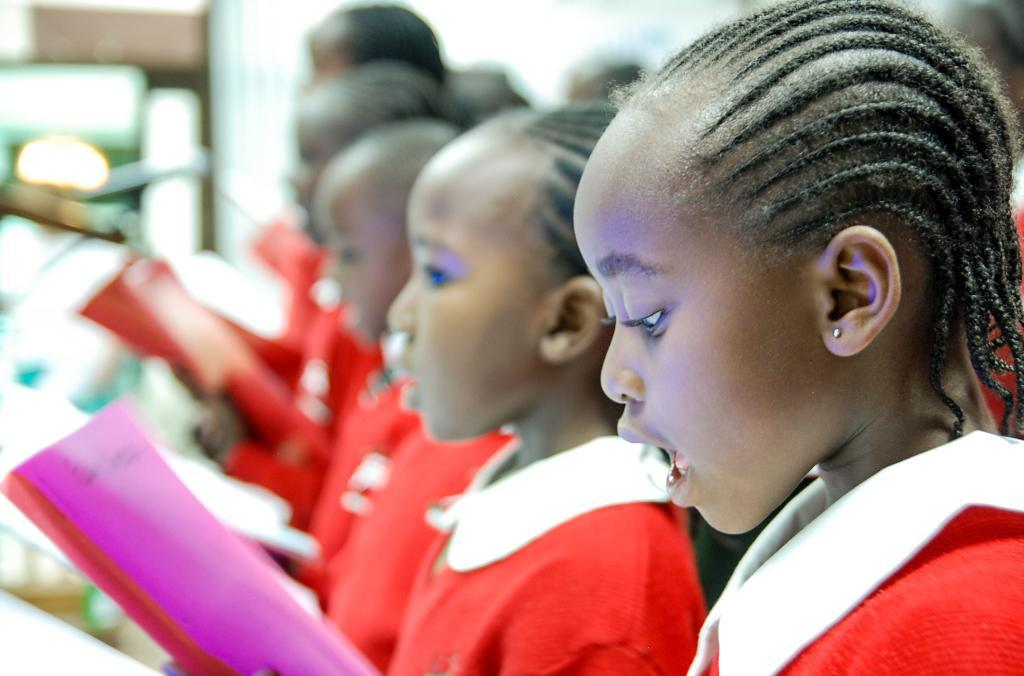What can be seen in the image? There is a group of people in the image. What are the people doing in the image? The people are holding objects in their hands. Can you describe the background of the image? The background of the image is blurred. How many bricks are visible in the image? There are no bricks present in the image. What type of kitten can be seen playing with the objects in the image? There is no kitten present in the image. 